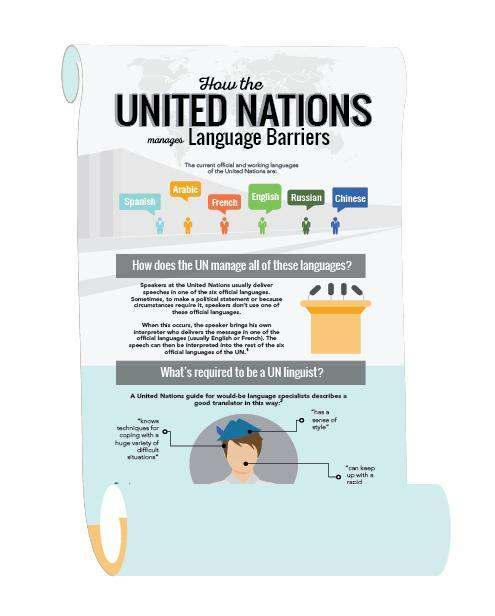How many official and working languages in United Nations?
Answer the question with a short phrase. 6 how many characteristics are defined to be a UN linguist 3 